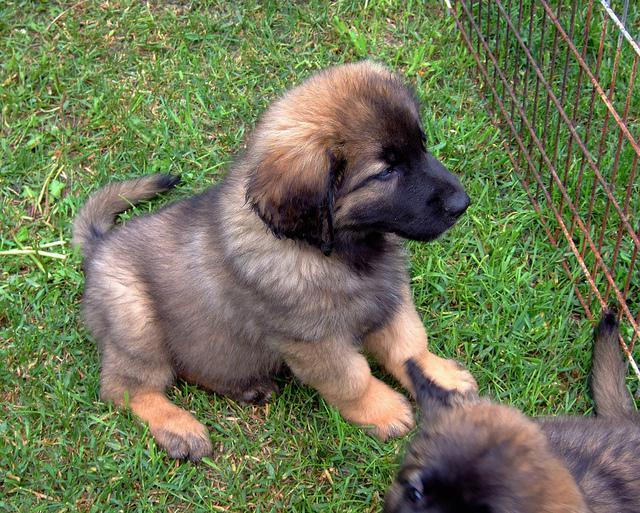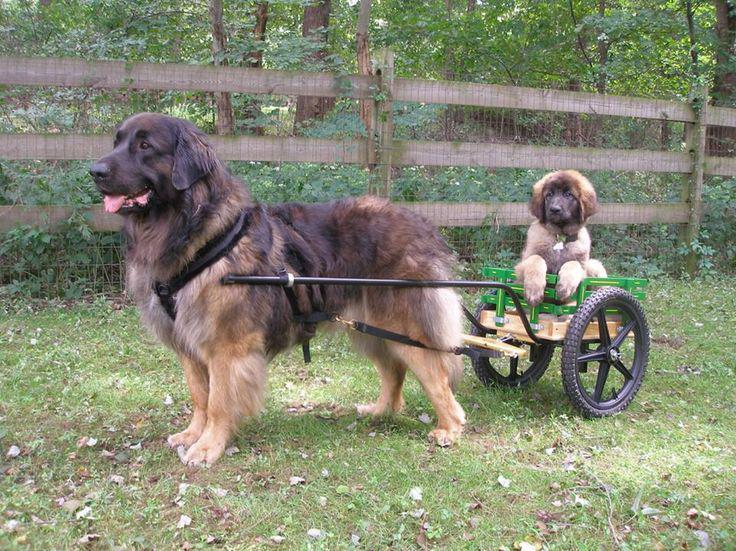The first image is the image on the left, the second image is the image on the right. Given the left and right images, does the statement "An image shows one big dog and one small dog outdoors." hold true? Answer yes or no. Yes. The first image is the image on the left, the second image is the image on the right. Considering the images on both sides, is "One image features two dogs, and adult and a puppy, in an outdoor setting." valid? Answer yes or no. Yes. 